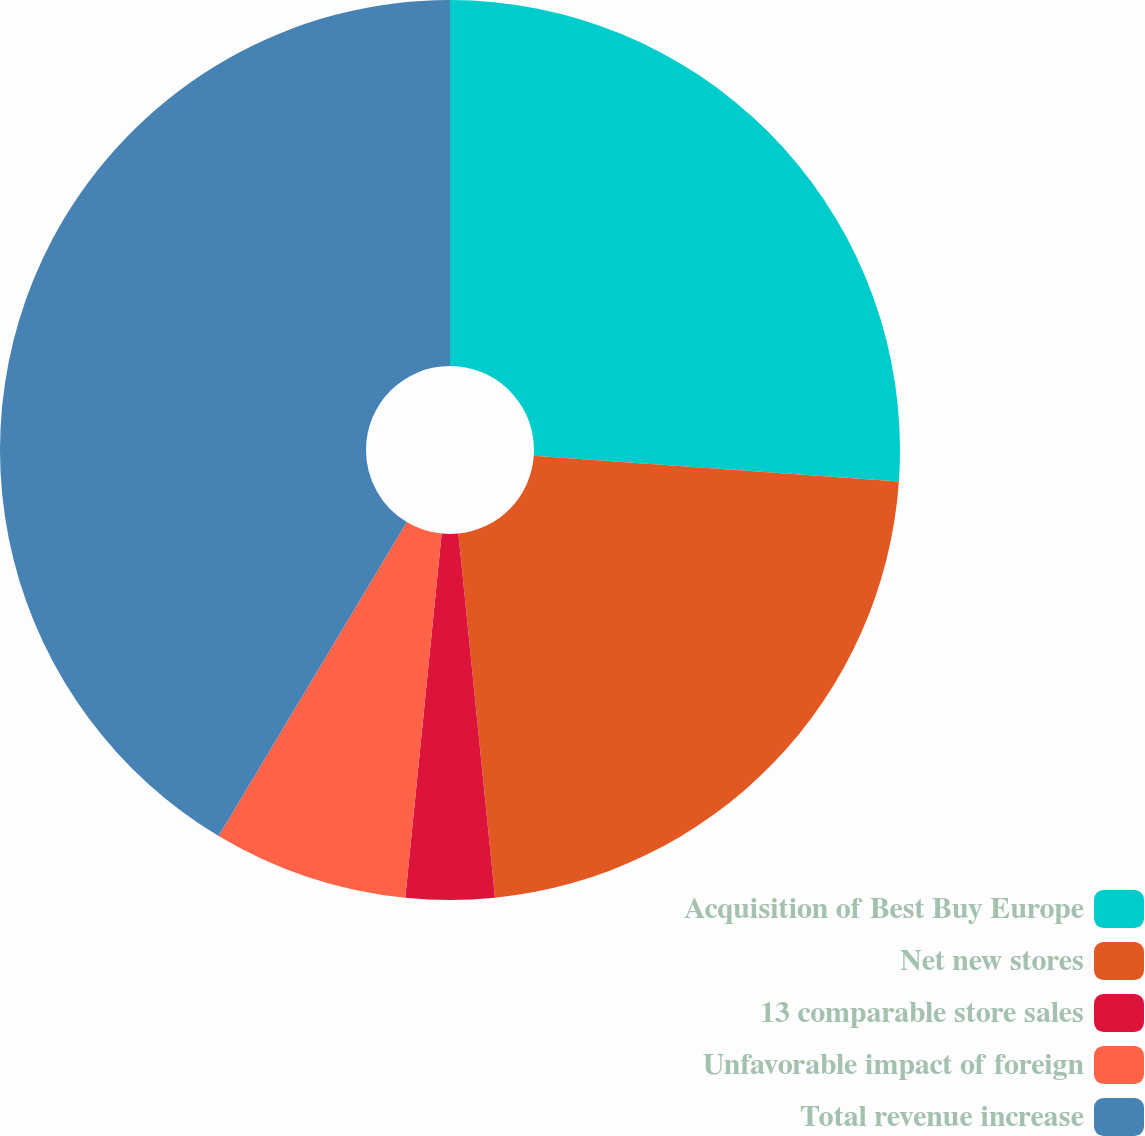<chart> <loc_0><loc_0><loc_500><loc_500><pie_chart><fcel>Acquisition of Best Buy Europe<fcel>Net new stores<fcel>13 comparable store sales<fcel>Unfavorable impact of foreign<fcel>Total revenue increase<nl><fcel>26.11%<fcel>22.29%<fcel>3.18%<fcel>7.01%<fcel>41.4%<nl></chart> 